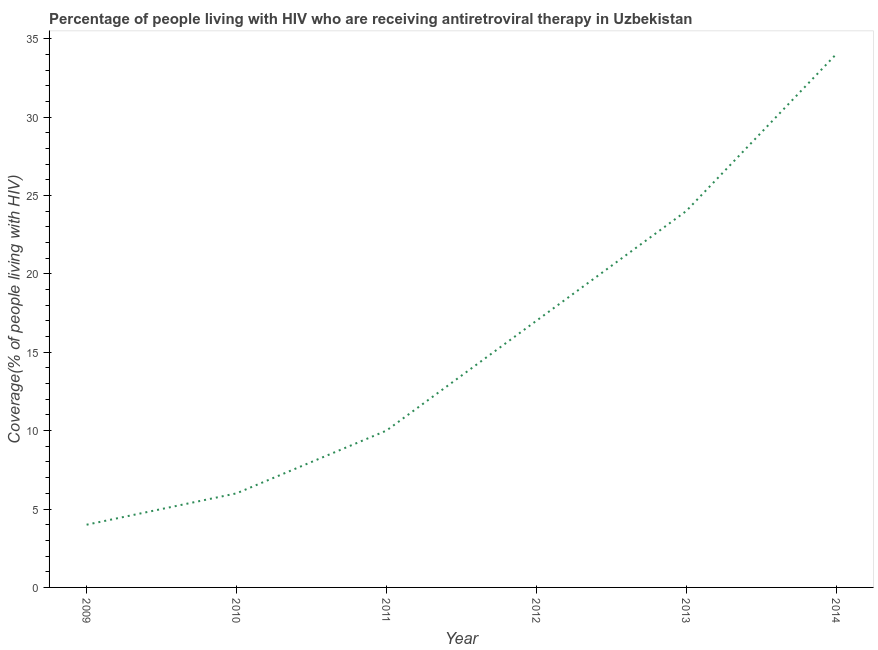What is the antiretroviral therapy coverage in 2009?
Your answer should be very brief. 4. Across all years, what is the maximum antiretroviral therapy coverage?
Your answer should be compact. 34. Across all years, what is the minimum antiretroviral therapy coverage?
Your answer should be very brief. 4. In which year was the antiretroviral therapy coverage minimum?
Your answer should be compact. 2009. What is the sum of the antiretroviral therapy coverage?
Provide a succinct answer. 95. What is the difference between the antiretroviral therapy coverage in 2012 and 2013?
Give a very brief answer. -7. What is the average antiretroviral therapy coverage per year?
Give a very brief answer. 15.83. What is the ratio of the antiretroviral therapy coverage in 2012 to that in 2013?
Your answer should be very brief. 0.71. Is the difference between the antiretroviral therapy coverage in 2010 and 2012 greater than the difference between any two years?
Provide a short and direct response. No. Is the sum of the antiretroviral therapy coverage in 2012 and 2014 greater than the maximum antiretroviral therapy coverage across all years?
Your response must be concise. Yes. What is the difference between the highest and the lowest antiretroviral therapy coverage?
Offer a terse response. 30. In how many years, is the antiretroviral therapy coverage greater than the average antiretroviral therapy coverage taken over all years?
Offer a very short reply. 3. Does the antiretroviral therapy coverage monotonically increase over the years?
Your response must be concise. Yes. What is the difference between two consecutive major ticks on the Y-axis?
Your answer should be compact. 5. Does the graph contain any zero values?
Provide a short and direct response. No. Does the graph contain grids?
Your answer should be very brief. No. What is the title of the graph?
Provide a succinct answer. Percentage of people living with HIV who are receiving antiretroviral therapy in Uzbekistan. What is the label or title of the Y-axis?
Offer a terse response. Coverage(% of people living with HIV). What is the difference between the Coverage(% of people living with HIV) in 2009 and 2011?
Offer a terse response. -6. What is the difference between the Coverage(% of people living with HIV) in 2009 and 2012?
Your answer should be very brief. -13. What is the difference between the Coverage(% of people living with HIV) in 2009 and 2013?
Provide a succinct answer. -20. What is the difference between the Coverage(% of people living with HIV) in 2010 and 2011?
Provide a succinct answer. -4. What is the difference between the Coverage(% of people living with HIV) in 2011 and 2012?
Offer a very short reply. -7. What is the difference between the Coverage(% of people living with HIV) in 2011 and 2014?
Your response must be concise. -24. What is the ratio of the Coverage(% of people living with HIV) in 2009 to that in 2010?
Your answer should be very brief. 0.67. What is the ratio of the Coverage(% of people living with HIV) in 2009 to that in 2011?
Your response must be concise. 0.4. What is the ratio of the Coverage(% of people living with HIV) in 2009 to that in 2012?
Make the answer very short. 0.23. What is the ratio of the Coverage(% of people living with HIV) in 2009 to that in 2013?
Your answer should be compact. 0.17. What is the ratio of the Coverage(% of people living with HIV) in 2009 to that in 2014?
Your response must be concise. 0.12. What is the ratio of the Coverage(% of people living with HIV) in 2010 to that in 2011?
Keep it short and to the point. 0.6. What is the ratio of the Coverage(% of people living with HIV) in 2010 to that in 2012?
Make the answer very short. 0.35. What is the ratio of the Coverage(% of people living with HIV) in 2010 to that in 2014?
Keep it short and to the point. 0.18. What is the ratio of the Coverage(% of people living with HIV) in 2011 to that in 2012?
Your response must be concise. 0.59. What is the ratio of the Coverage(% of people living with HIV) in 2011 to that in 2013?
Ensure brevity in your answer.  0.42. What is the ratio of the Coverage(% of people living with HIV) in 2011 to that in 2014?
Offer a terse response. 0.29. What is the ratio of the Coverage(% of people living with HIV) in 2012 to that in 2013?
Provide a short and direct response. 0.71. What is the ratio of the Coverage(% of people living with HIV) in 2013 to that in 2014?
Provide a succinct answer. 0.71. 